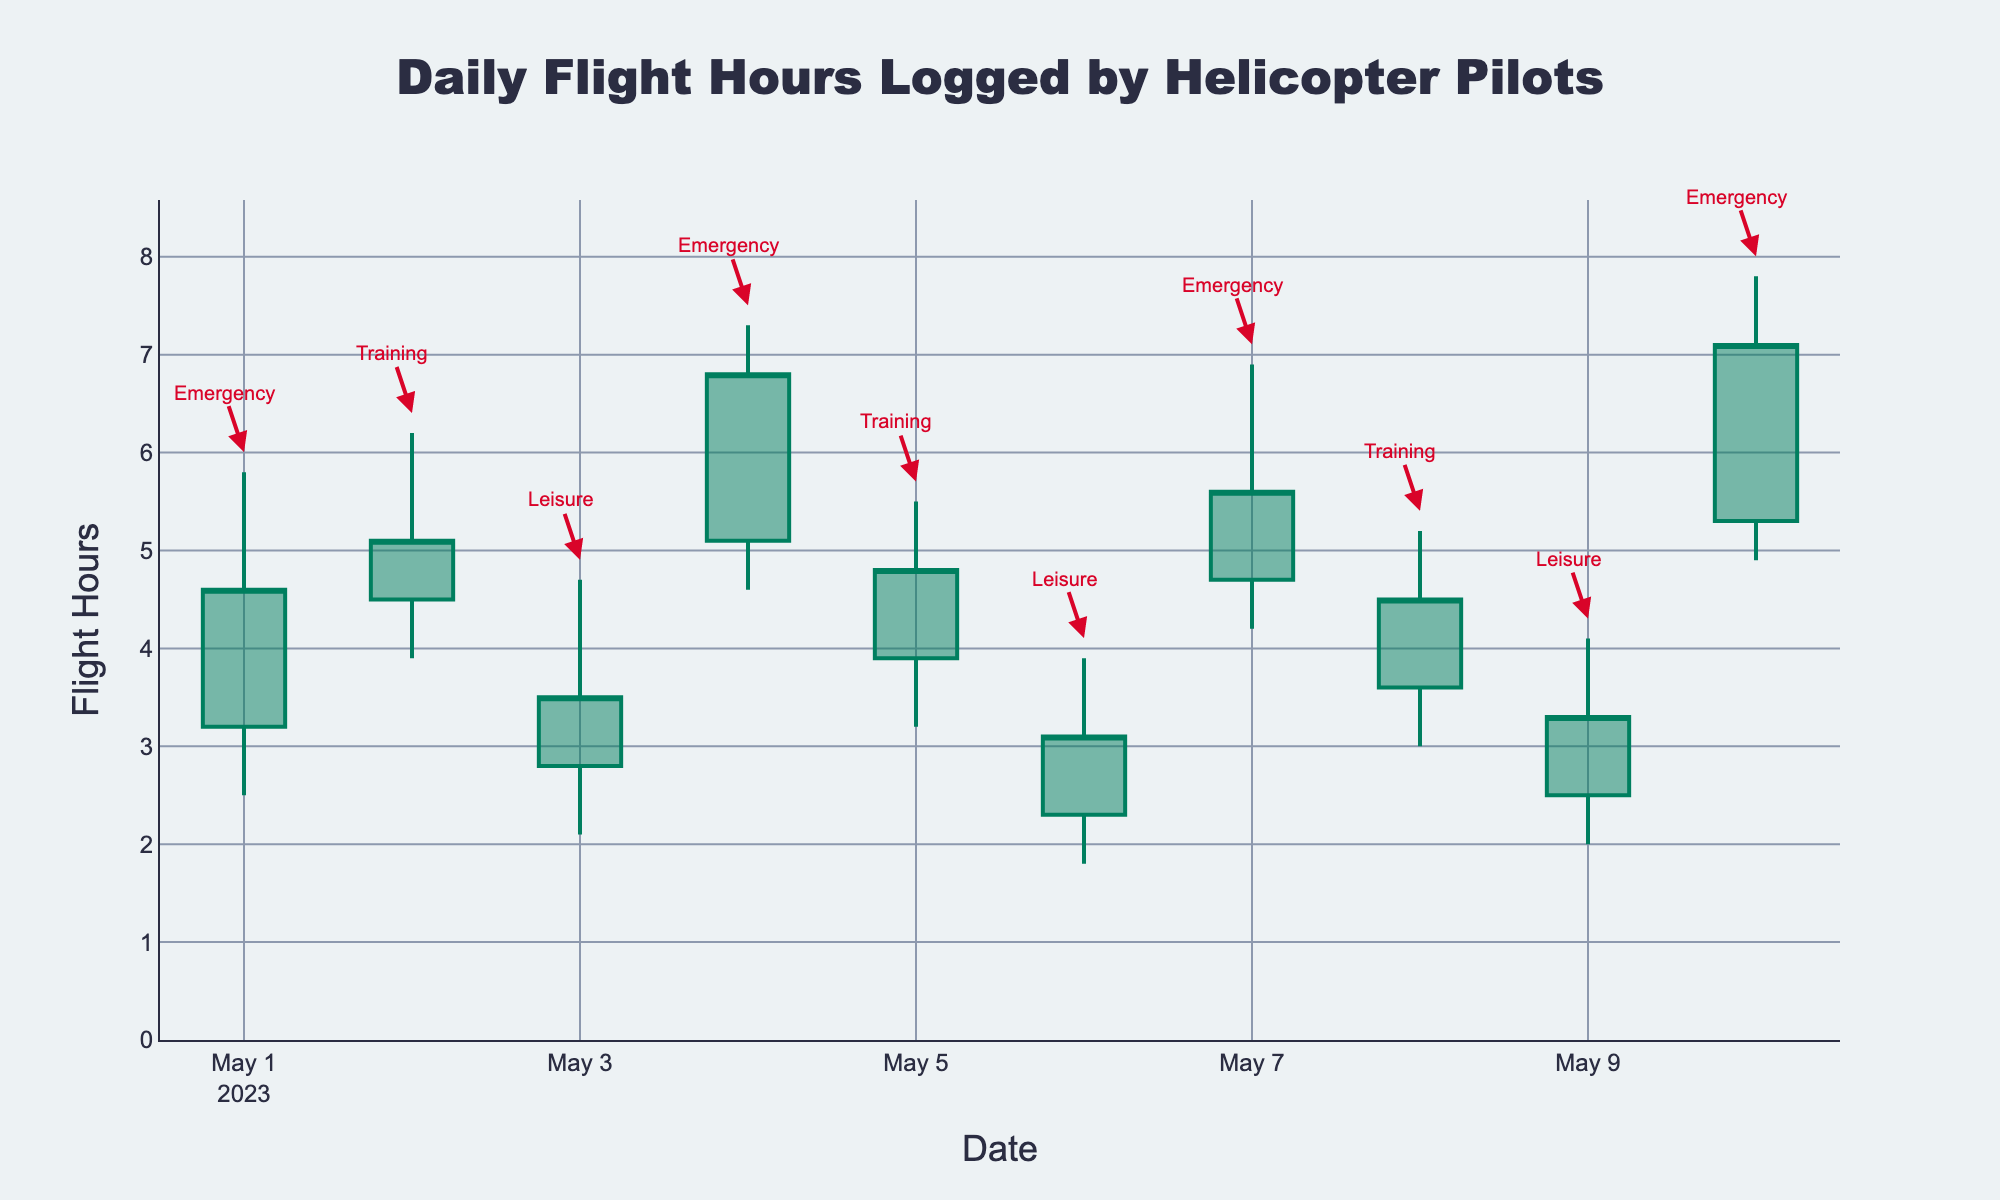What's the title of the chart? The title of the chart is typically located above the graph and summarizes the main topic of the visualization. In the provided figure, it's "Daily Flight Hours Logged by Helicopter Pilots."
Answer: Daily Flight Hours Logged by Helicopter Pilots How many days of data are shown in the figure? By counting the number of data points represented on the x-axis (dates) or the number of candlesticks in the plot, we can determine the number of days included in the data.
Answer: 10 Which type of flight shows the highest value for the high component? Looking for the highest value in the "High" column and then identifying the corresponding flight type will give us the desired answer. Here, the highest value is 7.8 on May 10th, which is for an Emergency flight.
Answer: Emergency On which date did leisure flights have the lowest closing value? By examining the closing values for leisure flights and locating the lowest point, we observe that the lowest closing value for leisure flights is 3.1, which occurred on May 6th.
Answer: May 6, 2023 Compare the open values for training flights on May 2nd and May 5th. Which one is higher? Check the open values for training flights on both dates: May 2nd has 4.5, and May 5th has 3.9. Therefore, the open value on May 2nd is higher.
Answer: May 2, 2023 What is the average close value of emergency flights? To find the average close value for emergency flights, sum their close values (4.6, 6.8, 5.6, 7.1) and divide by the number of emergency flights. The sum is 24.1, and there are 4 emergency flights, so the average is 24.1 / 4 = 6.025.
Answer: 6.025 How does the plot indicate whether a day had an increase or decrease in flight hours? In OHLC charts, the color of the candlestick (line) indicates changes: dark green for an increase (close > open) and dark red for a decrease (close < open).
Answer: Color of the candlestick Which date showed the greatest range in flight hours for Emergency flights? The range in flight hours is the difference between the high and low values. For Emergency flights, compare ranges for each date: May 1 (3.3), May 4 (2.7), May 7 (2.7), May 10 (2.9). The greatest range is 3.3 on May 1st.
Answer: May 1, 2023 What is the general trend of the closing values for Training flights over the given period? By observing the closing values of Training flights over the dates, we see the following closing values: May 2 (5.1), May 5 (4.8), May 8 (4.5). The trend is a decreasing trend over time.
Answer: Decreasing Which flight type had the smallest high value and what was it? By reviewing the high values for each flight type, we find the smallest high value corresponds to Leisure flights, with the smallest high at 3.9 on May 6th.
Answer: Leisure, 3.9 